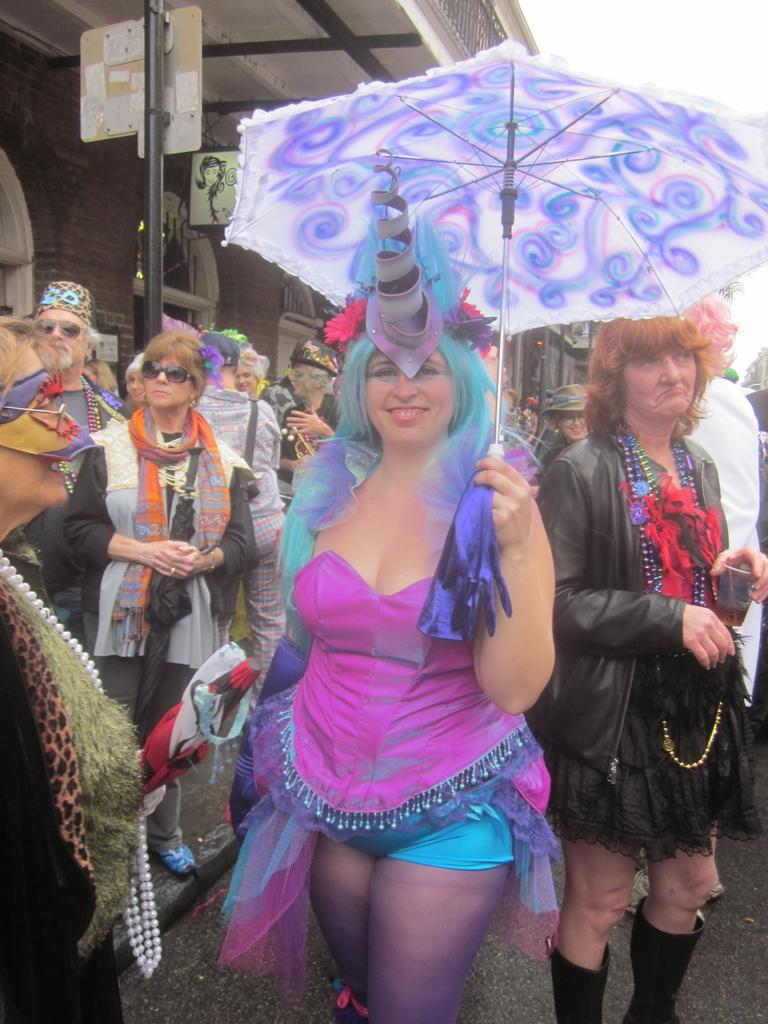What are the people in the image doing? The people in the image are standing on the road. Can you describe the woman in the image? The woman in the image is holding an umbrella in her hand. What is the reaction of the cast in the image? There is no reference to a cast or any performance in the image, so it's not possible to determine any reactions. 